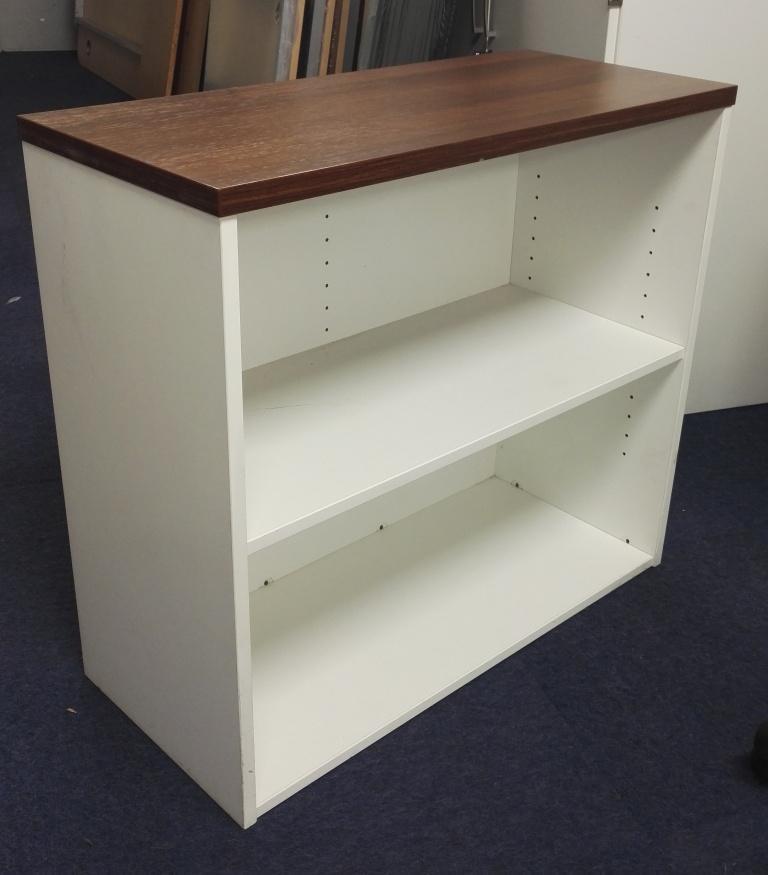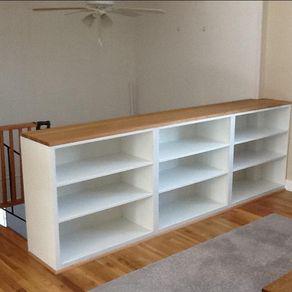The first image is the image on the left, the second image is the image on the right. For the images shown, is this caption "One shelving unit is narrow with only two inner levels, while a second shelving unit is much wider with three inner levels of shelves." true? Answer yes or no. Yes. The first image is the image on the left, the second image is the image on the right. Analyze the images presented: Is the assertion "There is something on the top and inside of a horizontal bookshelf unit, in one image." valid? Answer yes or no. No. 